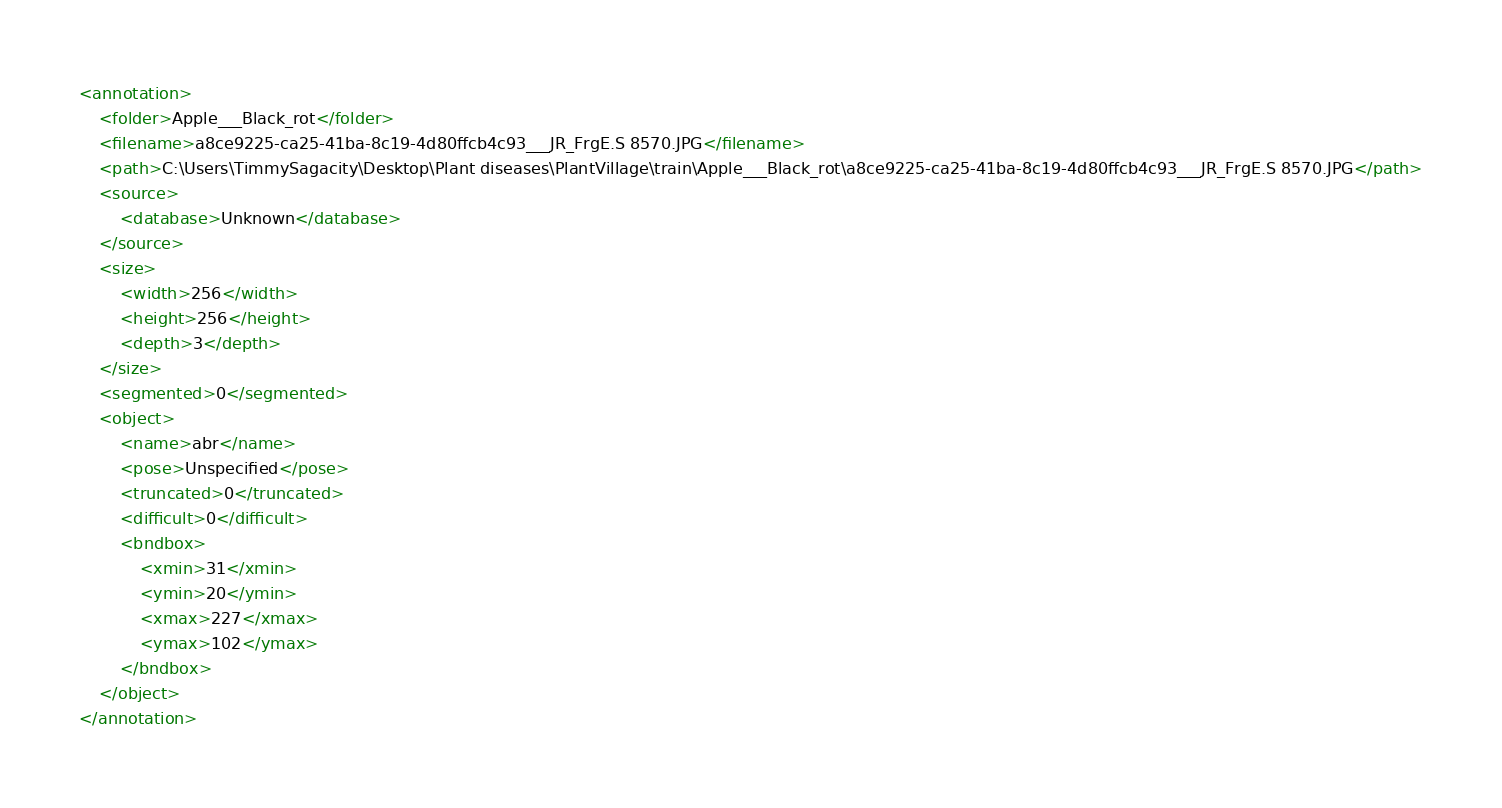<code> <loc_0><loc_0><loc_500><loc_500><_XML_><annotation>
	<folder>Apple___Black_rot</folder>
	<filename>a8ce9225-ca25-41ba-8c19-4d80ffcb4c93___JR_FrgE.S 8570.JPG</filename>
	<path>C:\Users\TimmySagacity\Desktop\Plant diseases\PlantVillage\train\Apple___Black_rot\a8ce9225-ca25-41ba-8c19-4d80ffcb4c93___JR_FrgE.S 8570.JPG</path>
	<source>
		<database>Unknown</database>
	</source>
	<size>
		<width>256</width>
		<height>256</height>
		<depth>3</depth>
	</size>
	<segmented>0</segmented>
	<object>
		<name>abr</name>
		<pose>Unspecified</pose>
		<truncated>0</truncated>
		<difficult>0</difficult>
		<bndbox>
			<xmin>31</xmin>
			<ymin>20</ymin>
			<xmax>227</xmax>
			<ymax>102</ymax>
		</bndbox>
	</object>
</annotation>
</code> 